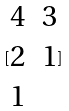<formula> <loc_0><loc_0><loc_500><loc_500>[ \begin{matrix} 4 & 3 \\ 2 & 1 \\ 1 \end{matrix} ]</formula> 